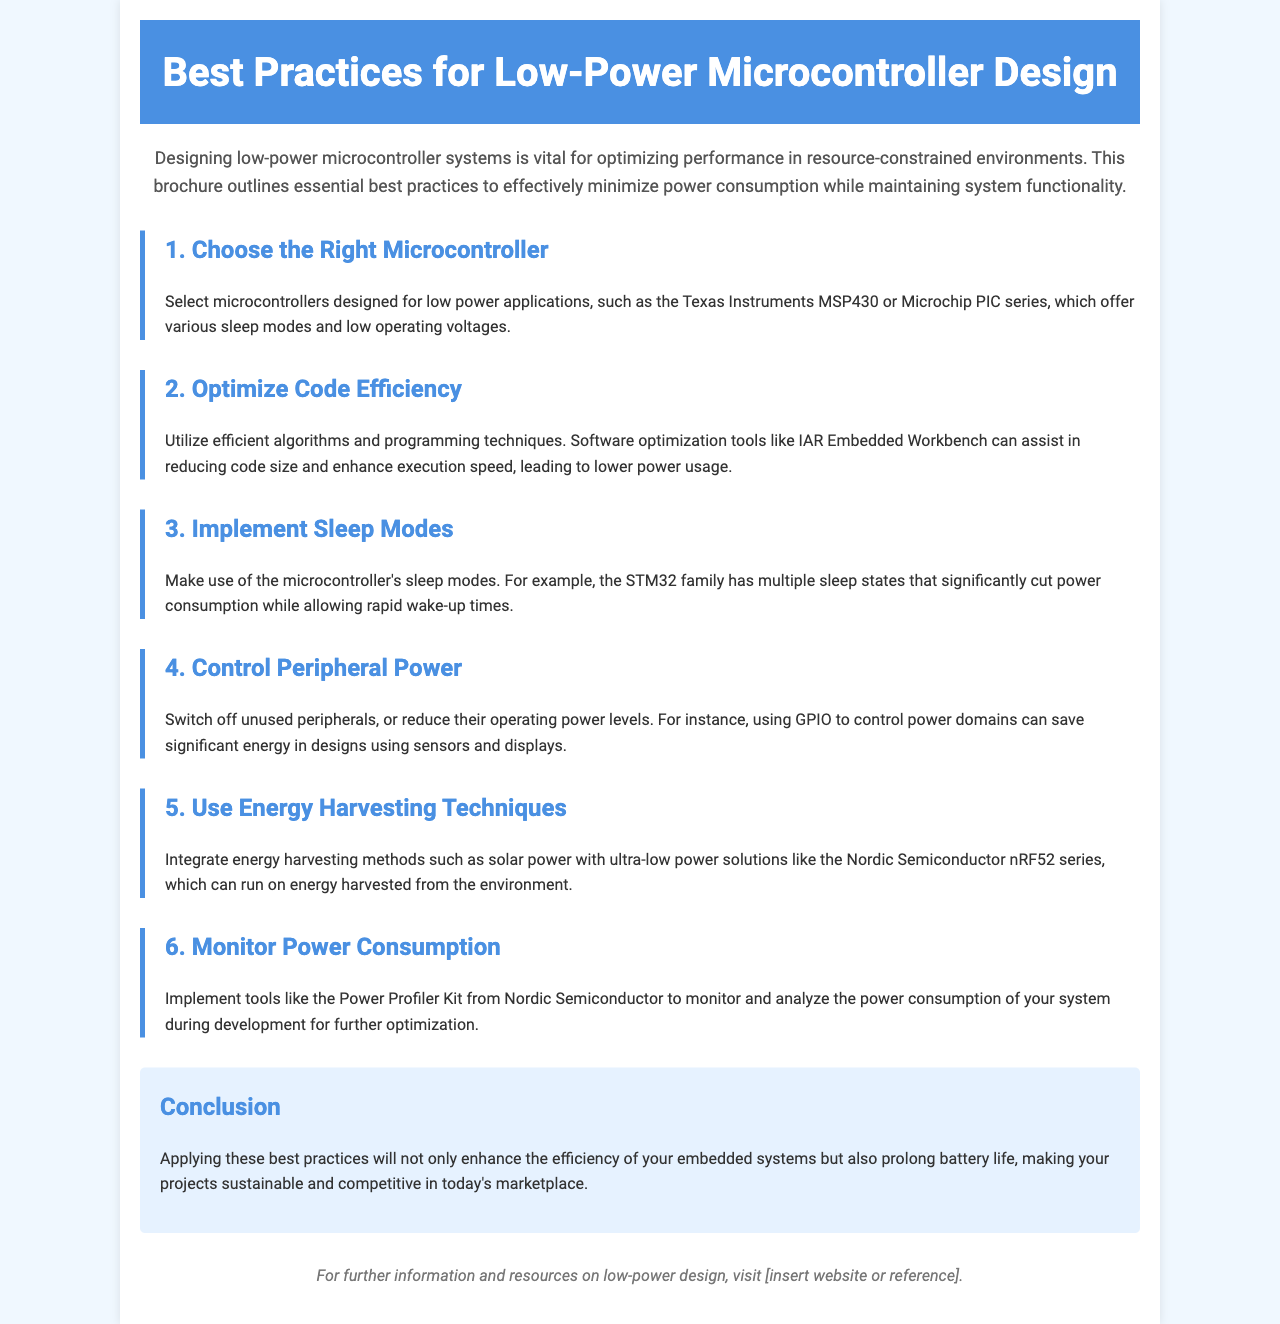What is the title of the brochure? The title is stated clearly in the header of the document.
Answer: Best Practices for Low-Power Microcontroller Design What is a recommended microcontroller series for low power applications? The document lists specific series as examples of suitable microcontrollers for low power.
Answer: Texas Instruments MSP430 What is one tool mentioned for optimizing code efficiency? The text specifies tools that aid in optimizing code size and execution speed.
Answer: IAR Embedded Workbench What should be controlled to reduce power consumption? The document emphasizes the importance of managing certain components to save energy.
Answer: Peripheral Power How many sections are dedicated to best practices in the brochure? The number of sections is explicitly indicated within the content.
Answer: 6 What energy harvesting technique is mentioned in the document? The document details a specific method for harvesting energy in low-power designs.
Answer: Solar power What is the main benefit of applying the best practices listed? The conclusion summarizes the primary advantage of utilizing these recommendations.
Answer: Prolong battery life What kit is suggested for monitoring power consumption? The document recommends a specific product to help in tracking energy usage.
Answer: Power Profiler Kit 